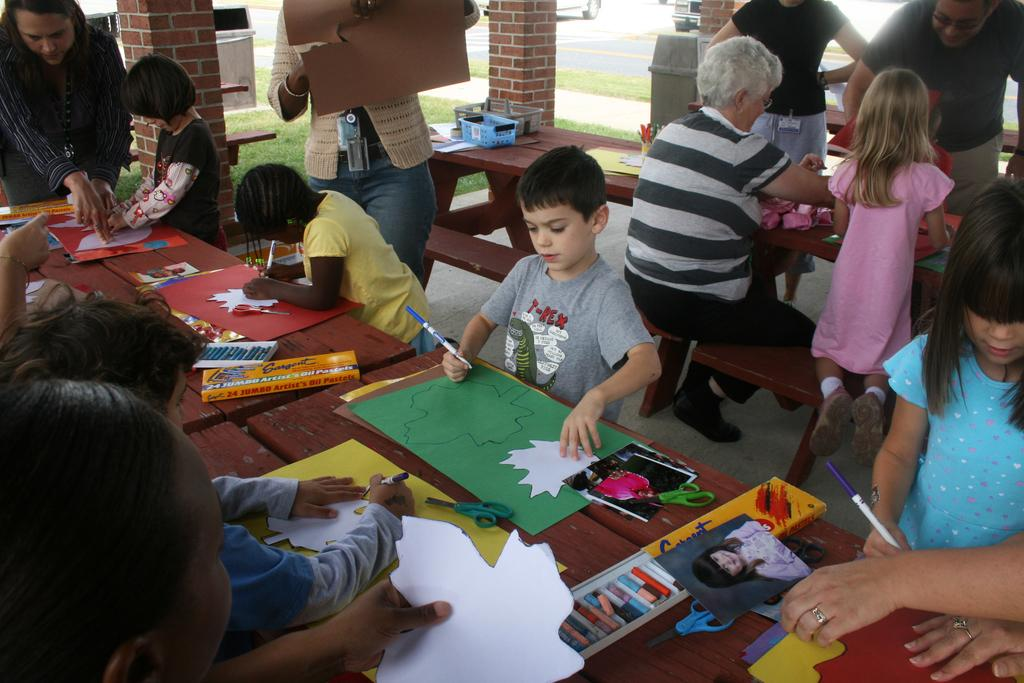What drawing or writing materials can be seen in the image? There are crayons and a pen in the image. What surface might be used for drawing or writing? There is a paper in the image that could be used for drawing or writing. What object is present that could hold or store items? There is a box in the image that could hold or store items. What is placed on the table in the image? Footwear is placed on a table in the image. What are the people in the image doing? People are sitting on a bench in the image. What type of natural environment is visible in the image? There is grass in the image, which suggests a natural environment. What type of transportation can be seen in the image? Vehicles are visible in the image. Can you tell me what type of doctor is present in the image? There is no doctor present in the image. What kind of system is being used to organize the vehicles in the image? There is no system for organizing vehicles visible in the image. 